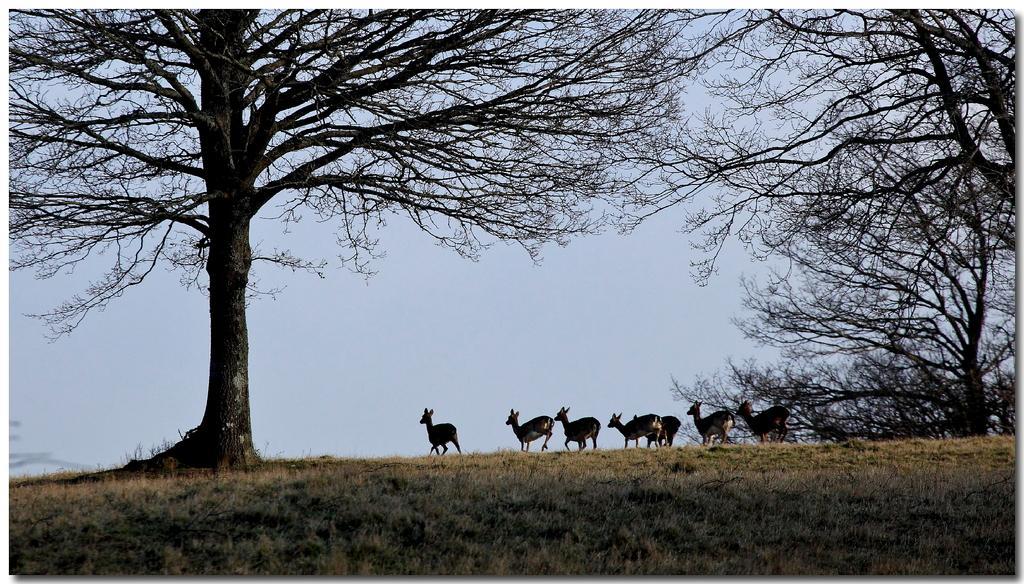Can you describe this image briefly? In this image I can see some grass on the ground, few animals and few trees on the ground. In the background I can see the sky. 